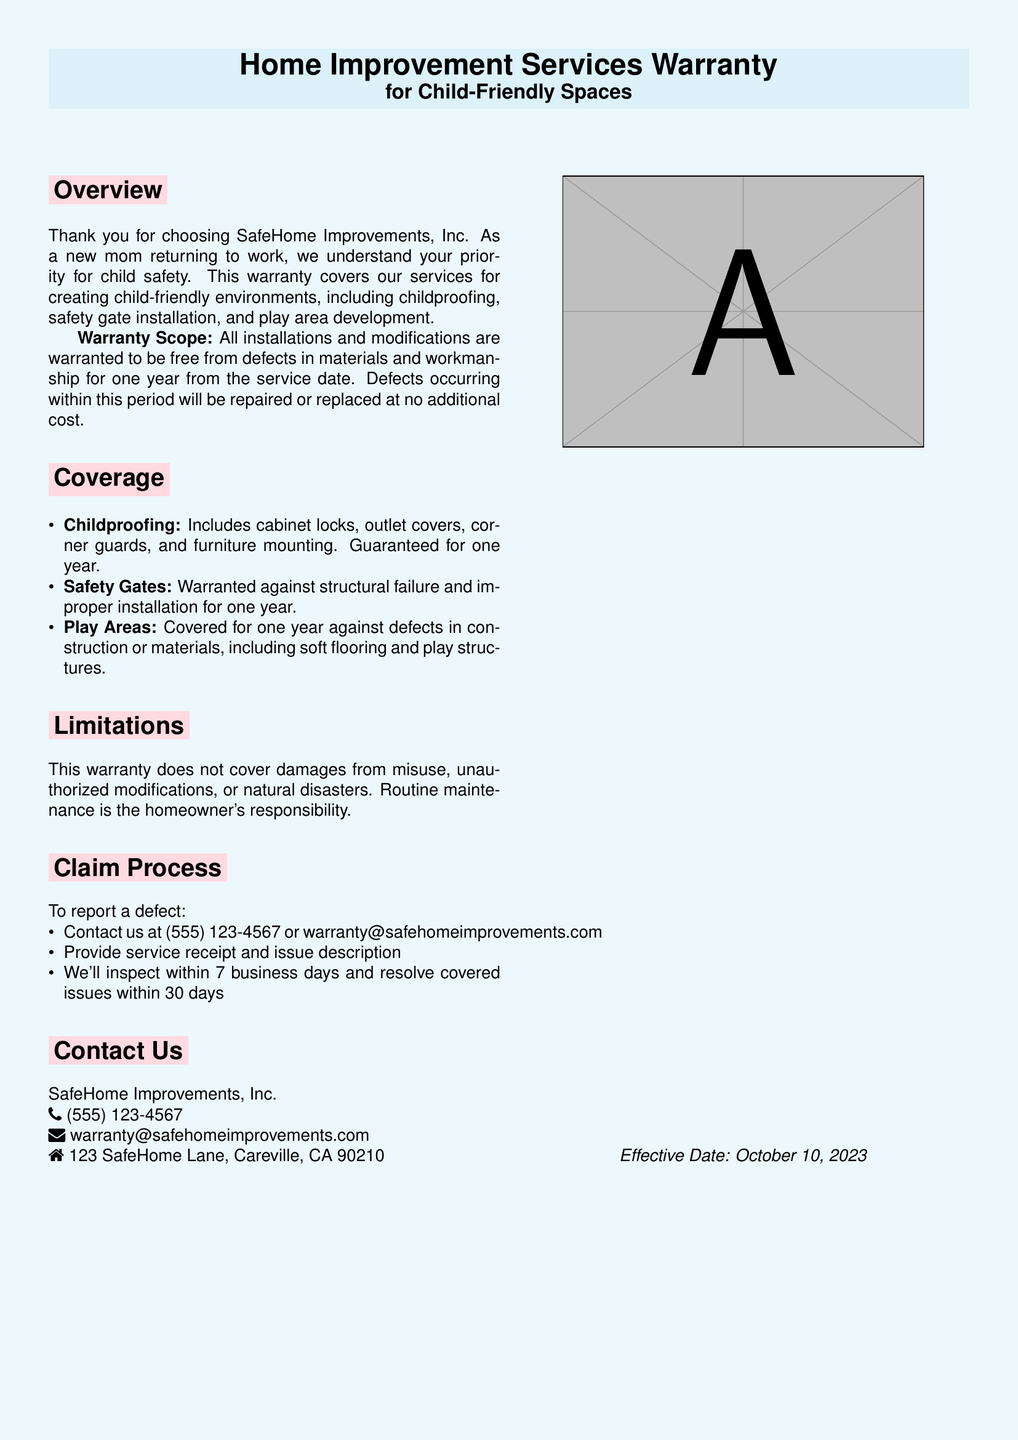What is the name of the company? The document mentions SafeHome Improvements, Inc. as the company providing the services covered by the warranty.
Answer: SafeHome Improvements, Inc What is the warranty period for installations? According to the document, all installations and modifications are warranted for one year from the service date.
Answer: One year What types of services are covered under the warranty? The document includes childproofing, safety gate installation, and play area development as covered services.
Answer: Childproofing, safety gate installation, play area development What should you provide to report a defect? The document specifies that you must provide the service receipt and a description of the issue to report a defect.
Answer: Service receipt and issue description What is not covered by the warranty? The limitations section details that damages from misuse, unauthorized modifications, or natural disasters are not covered.
Answer: Damages from misuse, unauthorized modifications, or natural disasters Who do you contact for warranty claims? The document contains the contact number and email for warranty claims, which are (555) 123-4567 and warranty@safehomeimprovements.com.
Answer: (555) 123-4567, warranty@safehomeimprovements.com What is the inspection timeline after reporting a defect? The warranty claims process states that the company will inspect the reported issue within 7 business days.
Answer: 7 business days When did the warranty become effective? The effective date is mentioned at the end of the document, indicating when the warranty starts.
Answer: October 10, 2023 